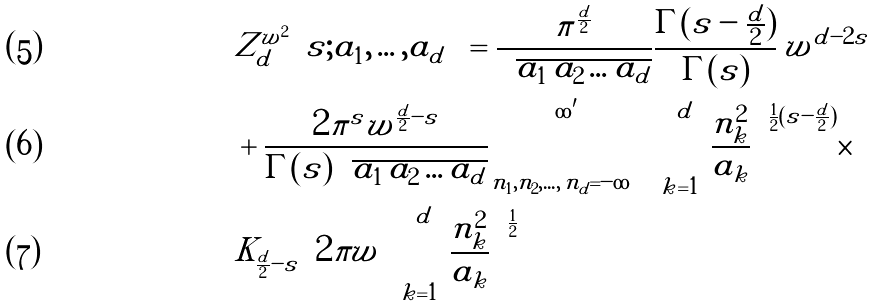Convert formula to latex. <formula><loc_0><loc_0><loc_500><loc_500>& Z _ { d } ^ { w ^ { 2 } } \Big { ( } s ; a _ { 1 } , \dots , a _ { d } \Big { ) } = \frac { \pi ^ { \frac { d } { 2 } } } { \sqrt { a _ { 1 } { \, } a _ { 2 } \dots a _ { d } } } \frac { \Gamma ( s - \frac { d } { 2 } ) } { \Gamma ( s ) } { \, } w ^ { d - 2 s } \\ & + \frac { 2 \pi ^ { s } w ^ { \frac { d } { 2 } - s } } { \Gamma ( s ) \sqrt { a _ { 1 } { \, } a _ { 2 } \dots a _ { d } } } \sum ^ { \infty ^ { \prime } } _ { n _ { 1 } , n _ { 2 } , \dots , { \, } n _ { d } = - \infty } \Big { [ } \sum _ { k = 1 } ^ { d } \frac { n _ { k } ^ { 2 } } { a _ { k } } \Big { ] } ^ { \frac { 1 } { 2 } ( s - \frac { d } { 2 } ) } \times \\ & K _ { \frac { d } { 2 } - s } \Big { ( } 2 \pi w \Big { [ } \sum _ { k = 1 } ^ { d } \frac { n _ { k } ^ { 2 } } { a _ { k } } \Big { ] } ^ { \frac { 1 } { 2 } } \Big { ) }</formula> 